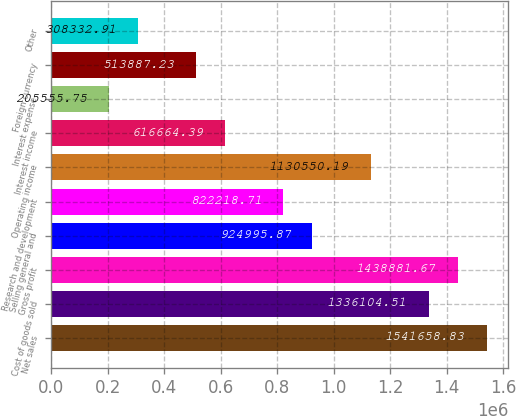<chart> <loc_0><loc_0><loc_500><loc_500><bar_chart><fcel>Net sales<fcel>Cost of goods sold<fcel>Gross profit<fcel>Selling general and<fcel>Research and development<fcel>Operating income<fcel>Interest income<fcel>Interest expense<fcel>Foreign currency<fcel>Other<nl><fcel>1.54166e+06<fcel>1.3361e+06<fcel>1.43888e+06<fcel>924996<fcel>822219<fcel>1.13055e+06<fcel>616664<fcel>205556<fcel>513887<fcel>308333<nl></chart> 